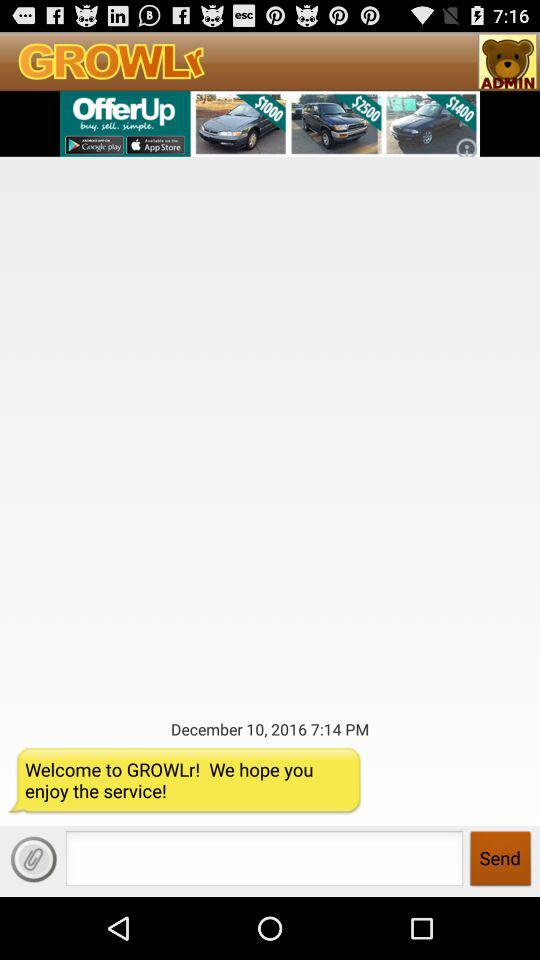What is the application name? The application name is "GROWLr". 